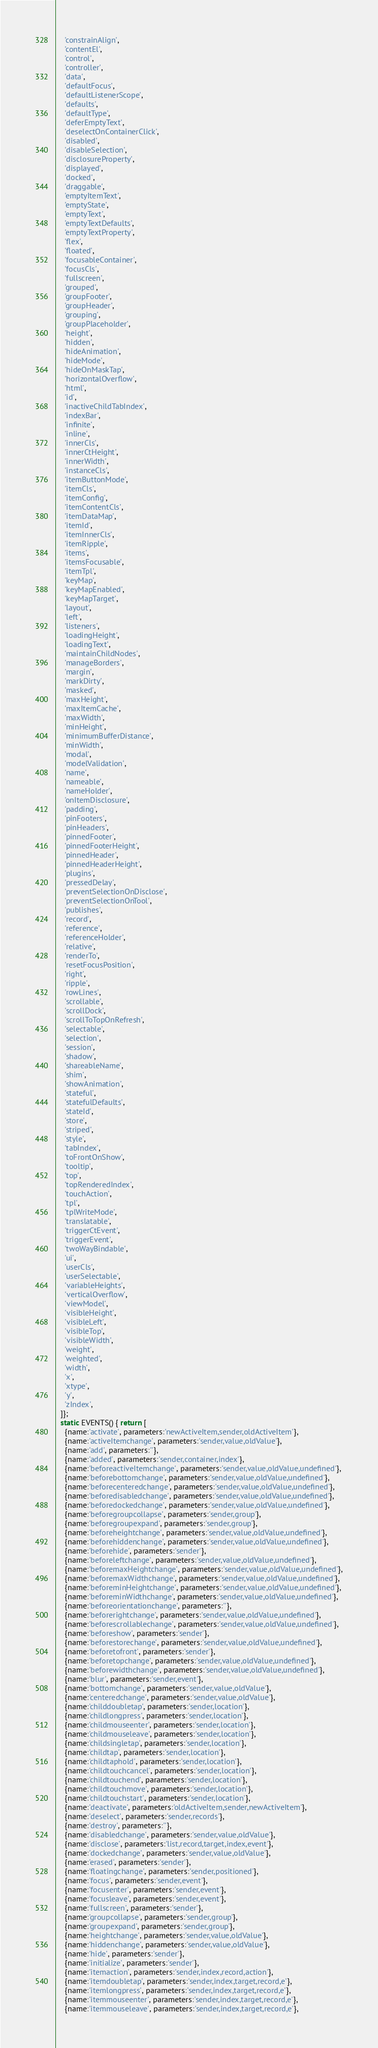<code> <loc_0><loc_0><loc_500><loc_500><_JavaScript_>    'constrainAlign',
    'contentEl',
    'control',
    'controller',
    'data',
    'defaultFocus',
    'defaultListenerScope',
    'defaults',
    'defaultType',
    'deferEmptyText',
    'deselectOnContainerClick',
    'disabled',
    'disableSelection',
    'disclosureProperty',
    'displayed',
    'docked',
    'draggable',
    'emptyItemText',
    'emptyState',
    'emptyText',
    'emptyTextDefaults',
    'emptyTextProperty',
    'flex',
    'floated',
    'focusableContainer',
    'focusCls',
    'fullscreen',
    'grouped',
    'groupFooter',
    'groupHeader',
    'grouping',
    'groupPlaceholder',
    'height',
    'hidden',
    'hideAnimation',
    'hideMode',
    'hideOnMaskTap',
    'horizontalOverflow',
    'html',
    'id',
    'inactiveChildTabIndex',
    'indexBar',
    'infinite',
    'inline',
    'innerCls',
    'innerCtHeight',
    'innerWidth',
    'instanceCls',
    'itemButtonMode',
    'itemCls',
    'itemConfig',
    'itemContentCls',
    'itemDataMap',
    'itemId',
    'itemInnerCls',
    'itemRipple',
    'items',
    'itemsFocusable',
    'itemTpl',
    'keyMap',
    'keyMapEnabled',
    'keyMapTarget',
    'layout',
    'left',
    'listeners',
    'loadingHeight',
    'loadingText',
    'maintainChildNodes',
    'manageBorders',
    'margin',
    'markDirty',
    'masked',
    'maxHeight',
    'maxItemCache',
    'maxWidth',
    'minHeight',
    'minimumBufferDistance',
    'minWidth',
    'modal',
    'modelValidation',
    'name',
    'nameable',
    'nameHolder',
    'onItemDisclosure',
    'padding',
    'pinFooters',
    'pinHeaders',
    'pinnedFooter',
    'pinnedFooterHeight',
    'pinnedHeader',
    'pinnedHeaderHeight',
    'plugins',
    'pressedDelay',
    'preventSelectionOnDisclose',
    'preventSelectionOnTool',
    'publishes',
    'record',
    'reference',
    'referenceHolder',
    'relative',
    'renderTo',
    'resetFocusPosition',
    'right',
    'ripple',
    'rowLines',
    'scrollable',
    'scrollDock',
    'scrollToTopOnRefresh',
    'selectable',
    'selection',
    'session',
    'shadow',
    'shareableName',
    'shim',
    'showAnimation',
    'stateful',
    'statefulDefaults',
    'stateId',
    'store',
    'striped',
    'style',
    'tabIndex',
    'toFrontOnShow',
    'tooltip',
    'top',
    'topRenderedIndex',
    'touchAction',
    'tpl',
    'tplWriteMode',
    'translatable',
    'triggerCtEvent',
    'triggerEvent',
    'twoWayBindable',
    'ui',
    'userCls',
    'userSelectable',
    'variableHeights',
    'verticalOverflow',
    'viewModel',
    'visibleHeight',
    'visibleLeft',
    'visibleTop',
    'visibleWidth',
    'weight',
    'weighted',
    'width',
    'x',
    'xtype',
    'y',
    'zIndex',
  ]};
  static EVENTS() { return [
    {name:'activate', parameters:'newActiveItem,sender,oldActiveItem'},
    {name:'activeItemchange', parameters:'sender,value,oldValue'},
    {name:'add', parameters:''},
    {name:'added', parameters:'sender,container,index'},
    {name:'beforeactiveItemchange', parameters:'sender,value,oldValue,undefined'},
    {name:'beforebottomchange', parameters:'sender,value,oldValue,undefined'},
    {name:'beforecenteredchange', parameters:'sender,value,oldValue,undefined'},
    {name:'beforedisabledchange', parameters:'sender,value,oldValue,undefined'},
    {name:'beforedockedchange', parameters:'sender,value,oldValue,undefined'},
    {name:'beforegroupcollapse', parameters:'sender,group'},
    {name:'beforegroupexpand', parameters:'sender,group'},
    {name:'beforeheightchange', parameters:'sender,value,oldValue,undefined'},
    {name:'beforehiddenchange', parameters:'sender,value,oldValue,undefined'},
    {name:'beforehide', parameters:'sender'},
    {name:'beforeleftchange', parameters:'sender,value,oldValue,undefined'},
    {name:'beforemaxHeightchange', parameters:'sender,value,oldValue,undefined'},
    {name:'beforemaxWidthchange', parameters:'sender,value,oldValue,undefined'},
    {name:'beforeminHeightchange', parameters:'sender,value,oldValue,undefined'},
    {name:'beforeminWidthchange', parameters:'sender,value,oldValue,undefined'},
    {name:'beforeorientationchange', parameters:''},
    {name:'beforerightchange', parameters:'sender,value,oldValue,undefined'},
    {name:'beforescrollablechange', parameters:'sender,value,oldValue,undefined'},
    {name:'beforeshow', parameters:'sender'},
    {name:'beforestorechange', parameters:'sender,value,oldValue,undefined'},
    {name:'beforetofront', parameters:'sender'},
    {name:'beforetopchange', parameters:'sender,value,oldValue,undefined'},
    {name:'beforewidthchange', parameters:'sender,value,oldValue,undefined'},
    {name:'blur', parameters:'sender,event'},
    {name:'bottomchange', parameters:'sender,value,oldValue'},
    {name:'centeredchange', parameters:'sender,value,oldValue'},
    {name:'childdoubletap', parameters:'sender,location'},
    {name:'childlongpress', parameters:'sender,location'},
    {name:'childmouseenter', parameters:'sender,location'},
    {name:'childmouseleave', parameters:'sender,location'},
    {name:'childsingletap', parameters:'sender,location'},
    {name:'childtap', parameters:'sender,location'},
    {name:'childtaphold', parameters:'sender,location'},
    {name:'childtouchcancel', parameters:'sender,location'},
    {name:'childtouchend', parameters:'sender,location'},
    {name:'childtouchmove', parameters:'sender,location'},
    {name:'childtouchstart', parameters:'sender,location'},
    {name:'deactivate', parameters:'oldActiveItem,sender,newActiveItem'},
    {name:'deselect', parameters:'sender,records'},
    {name:'destroy', parameters:''},
    {name:'disabledchange', parameters:'sender,value,oldValue'},
    {name:'disclose', parameters:'list,record,target,index,event'},
    {name:'dockedchange', parameters:'sender,value,oldValue'},
    {name:'erased', parameters:'sender'},
    {name:'floatingchange', parameters:'sender,positioned'},
    {name:'focus', parameters:'sender,event'},
    {name:'focusenter', parameters:'sender,event'},
    {name:'focusleave', parameters:'sender,event'},
    {name:'fullscreen', parameters:'sender'},
    {name:'groupcollapse', parameters:'sender,group'},
    {name:'groupexpand', parameters:'sender,group'},
    {name:'heightchange', parameters:'sender,value,oldValue'},
    {name:'hiddenchange', parameters:'sender,value,oldValue'},
    {name:'hide', parameters:'sender'},
    {name:'initialize', parameters:'sender'},
    {name:'itemaction', parameters:'sender,index,record,action'},
    {name:'itemdoubletap', parameters:'sender,index,target,record,e'},
    {name:'itemlongpress', parameters:'sender,index,target,record,e'},
    {name:'itemmouseenter', parameters:'sender,index,target,record,e'},
    {name:'itemmouseleave', parameters:'sender,index,target,record,e'},</code> 